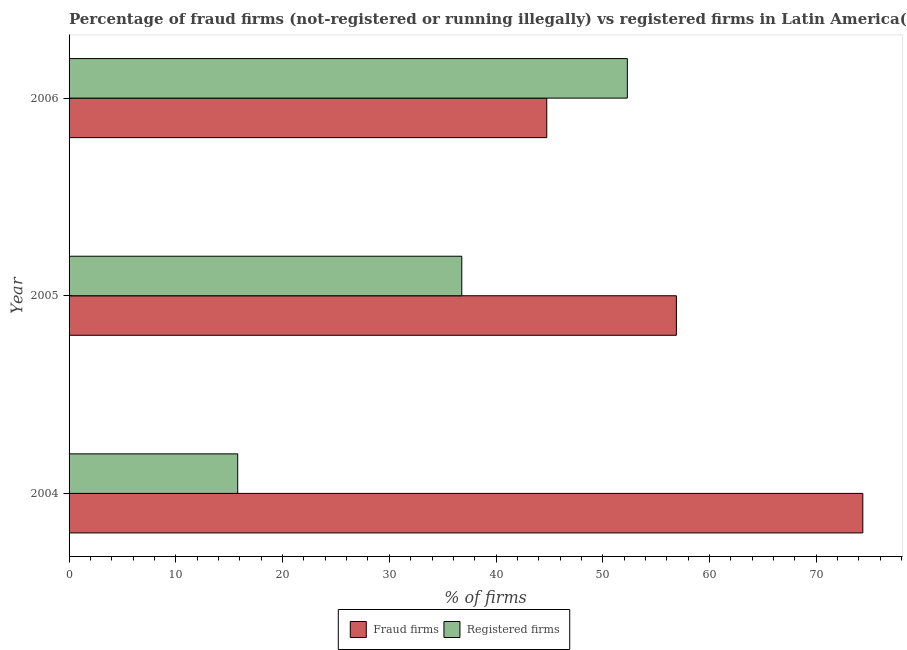How many different coloured bars are there?
Your answer should be very brief. 2. Are the number of bars on each tick of the Y-axis equal?
Make the answer very short. Yes. How many bars are there on the 3rd tick from the top?
Offer a terse response. 2. In how many cases, is the number of bars for a given year not equal to the number of legend labels?
Provide a short and direct response. 0. What is the percentage of fraud firms in 2004?
Your answer should be compact. 74.36. Across all years, what is the maximum percentage of fraud firms?
Give a very brief answer. 74.36. Across all years, what is the minimum percentage of fraud firms?
Ensure brevity in your answer.  44.75. In which year was the percentage of fraud firms maximum?
Your response must be concise. 2004. What is the total percentage of registered firms in the graph?
Your response must be concise. 104.89. What is the difference between the percentage of fraud firms in 2004 and that in 2006?
Your answer should be very brief. 29.61. What is the difference between the percentage of registered firms in 2005 and the percentage of fraud firms in 2004?
Provide a short and direct response. -37.57. What is the average percentage of fraud firms per year?
Offer a terse response. 58.67. In the year 2006, what is the difference between the percentage of registered firms and percentage of fraud firms?
Make the answer very short. 7.55. What is the ratio of the percentage of fraud firms in 2005 to that in 2006?
Offer a very short reply. 1.27. What is the difference between the highest and the second highest percentage of registered firms?
Provide a short and direct response. 15.51. What is the difference between the highest and the lowest percentage of registered firms?
Keep it short and to the point. 36.5. In how many years, is the percentage of registered firms greater than the average percentage of registered firms taken over all years?
Offer a very short reply. 2. What does the 1st bar from the top in 2004 represents?
Keep it short and to the point. Registered firms. What does the 2nd bar from the bottom in 2006 represents?
Your response must be concise. Registered firms. How many years are there in the graph?
Offer a terse response. 3. What is the difference between two consecutive major ticks on the X-axis?
Make the answer very short. 10. Does the graph contain any zero values?
Make the answer very short. No. Does the graph contain grids?
Give a very brief answer. No. What is the title of the graph?
Your answer should be compact. Percentage of fraud firms (not-registered or running illegally) vs registered firms in Latin America(developing only). What is the label or title of the X-axis?
Offer a very short reply. % of firms. What is the % of firms of Fraud firms in 2004?
Give a very brief answer. 74.36. What is the % of firms in Registered firms in 2004?
Make the answer very short. 15.8. What is the % of firms of Fraud firms in 2005?
Give a very brief answer. 56.9. What is the % of firms of Registered firms in 2005?
Provide a succinct answer. 36.79. What is the % of firms in Fraud firms in 2006?
Make the answer very short. 44.75. What is the % of firms of Registered firms in 2006?
Provide a short and direct response. 52.3. Across all years, what is the maximum % of firms in Fraud firms?
Your answer should be compact. 74.36. Across all years, what is the maximum % of firms in Registered firms?
Offer a very short reply. 52.3. Across all years, what is the minimum % of firms in Fraud firms?
Offer a very short reply. 44.75. What is the total % of firms in Fraud firms in the graph?
Give a very brief answer. 176.01. What is the total % of firms of Registered firms in the graph?
Provide a succinct answer. 104.89. What is the difference between the % of firms of Fraud firms in 2004 and that in 2005?
Ensure brevity in your answer.  17.46. What is the difference between the % of firms in Registered firms in 2004 and that in 2005?
Your answer should be very brief. -20.99. What is the difference between the % of firms of Fraud firms in 2004 and that in 2006?
Ensure brevity in your answer.  29.61. What is the difference between the % of firms of Registered firms in 2004 and that in 2006?
Make the answer very short. -36.5. What is the difference between the % of firms in Fraud firms in 2005 and that in 2006?
Your answer should be very brief. 12.14. What is the difference between the % of firms in Registered firms in 2005 and that in 2006?
Your answer should be very brief. -15.51. What is the difference between the % of firms of Fraud firms in 2004 and the % of firms of Registered firms in 2005?
Provide a short and direct response. 37.57. What is the difference between the % of firms in Fraud firms in 2004 and the % of firms in Registered firms in 2006?
Your answer should be very brief. 22.06. What is the difference between the % of firms of Fraud firms in 2005 and the % of firms of Registered firms in 2006?
Your answer should be very brief. 4.6. What is the average % of firms in Fraud firms per year?
Keep it short and to the point. 58.67. What is the average % of firms in Registered firms per year?
Your answer should be very brief. 34.96. In the year 2004, what is the difference between the % of firms of Fraud firms and % of firms of Registered firms?
Your answer should be compact. 58.56. In the year 2005, what is the difference between the % of firms in Fraud firms and % of firms in Registered firms?
Your answer should be compact. 20.11. In the year 2006, what is the difference between the % of firms in Fraud firms and % of firms in Registered firms?
Your answer should be very brief. -7.55. What is the ratio of the % of firms of Fraud firms in 2004 to that in 2005?
Your answer should be very brief. 1.31. What is the ratio of the % of firms in Registered firms in 2004 to that in 2005?
Keep it short and to the point. 0.43. What is the ratio of the % of firms in Fraud firms in 2004 to that in 2006?
Make the answer very short. 1.66. What is the ratio of the % of firms in Registered firms in 2004 to that in 2006?
Keep it short and to the point. 0.3. What is the ratio of the % of firms in Fraud firms in 2005 to that in 2006?
Offer a very short reply. 1.27. What is the ratio of the % of firms of Registered firms in 2005 to that in 2006?
Keep it short and to the point. 0.7. What is the difference between the highest and the second highest % of firms of Fraud firms?
Offer a very short reply. 17.46. What is the difference between the highest and the second highest % of firms in Registered firms?
Make the answer very short. 15.51. What is the difference between the highest and the lowest % of firms in Fraud firms?
Provide a succinct answer. 29.61. What is the difference between the highest and the lowest % of firms in Registered firms?
Ensure brevity in your answer.  36.5. 